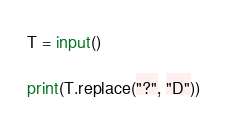<code> <loc_0><loc_0><loc_500><loc_500><_Python_>T = input()

print(T.replace("?", "D"))</code> 